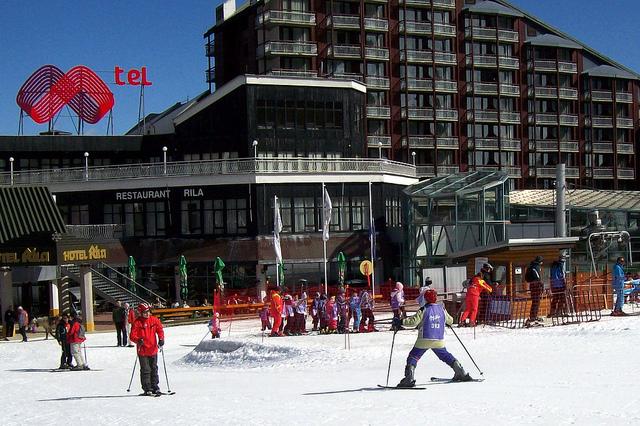Are the umbrellas on the deck outside of the restaurant opened?
Write a very short answer. No. How many balconies do you see?
Quick response, please. 1. Is the girl running with the kite?
Answer briefly. No. How many steps are there?
Short answer required. 20. What is covering the ground?
Write a very short answer. Snow. Will any children be skiing?
Answer briefly. Yes. 